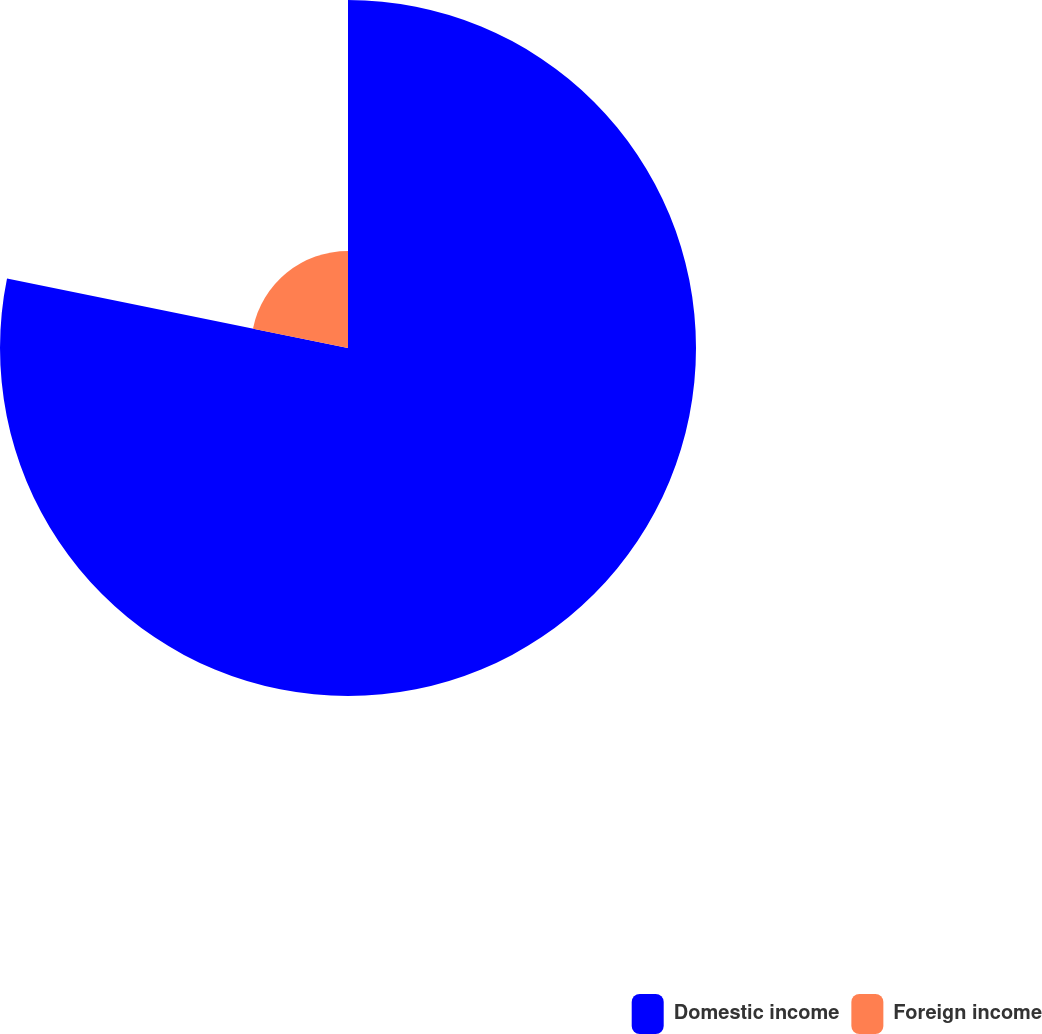Convert chart. <chart><loc_0><loc_0><loc_500><loc_500><pie_chart><fcel>Domestic income<fcel>Foreign income<nl><fcel>78.2%<fcel>21.8%<nl></chart> 